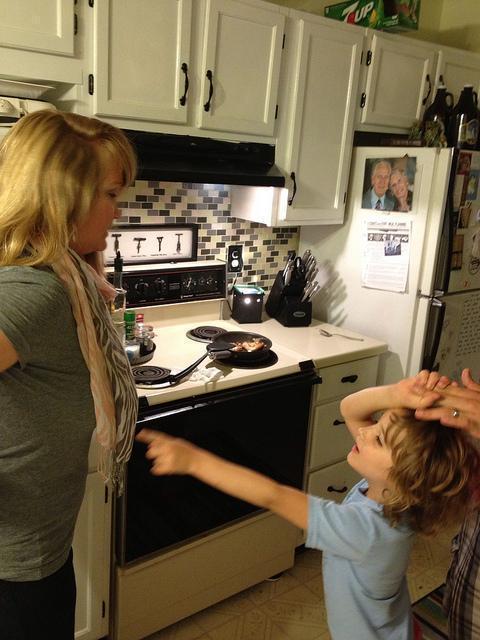What is the original flavor of the beverage?
Select the accurate response from the four choices given to answer the question.
Options: Orange, grape, cherry, lemon-lime. Lemon-lime. 